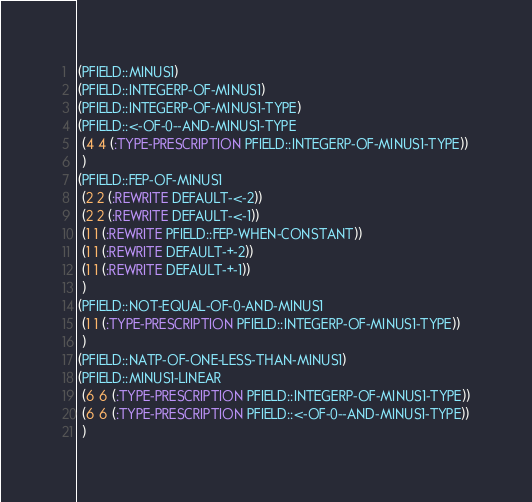<code> <loc_0><loc_0><loc_500><loc_500><_Lisp_>(PFIELD::MINUS1)
(PFIELD::INTEGERP-OF-MINUS1)
(PFIELD::INTEGERP-OF-MINUS1-TYPE)
(PFIELD::<-OF-0--AND-MINUS1-TYPE
 (4 4 (:TYPE-PRESCRIPTION PFIELD::INTEGERP-OF-MINUS1-TYPE))
 )
(PFIELD::FEP-OF-MINUS1
 (2 2 (:REWRITE DEFAULT-<-2))
 (2 2 (:REWRITE DEFAULT-<-1))
 (1 1 (:REWRITE PFIELD::FEP-WHEN-CONSTANT))
 (1 1 (:REWRITE DEFAULT-+-2))
 (1 1 (:REWRITE DEFAULT-+-1))
 )
(PFIELD::NOT-EQUAL-OF-0-AND-MINUS1
 (1 1 (:TYPE-PRESCRIPTION PFIELD::INTEGERP-OF-MINUS1-TYPE))
 )
(PFIELD::NATP-OF-ONE-LESS-THAN-MINUS1)
(PFIELD::MINUS1-LINEAR
 (6 6 (:TYPE-PRESCRIPTION PFIELD::INTEGERP-OF-MINUS1-TYPE))
 (6 6 (:TYPE-PRESCRIPTION PFIELD::<-OF-0--AND-MINUS1-TYPE))
 )
</code> 